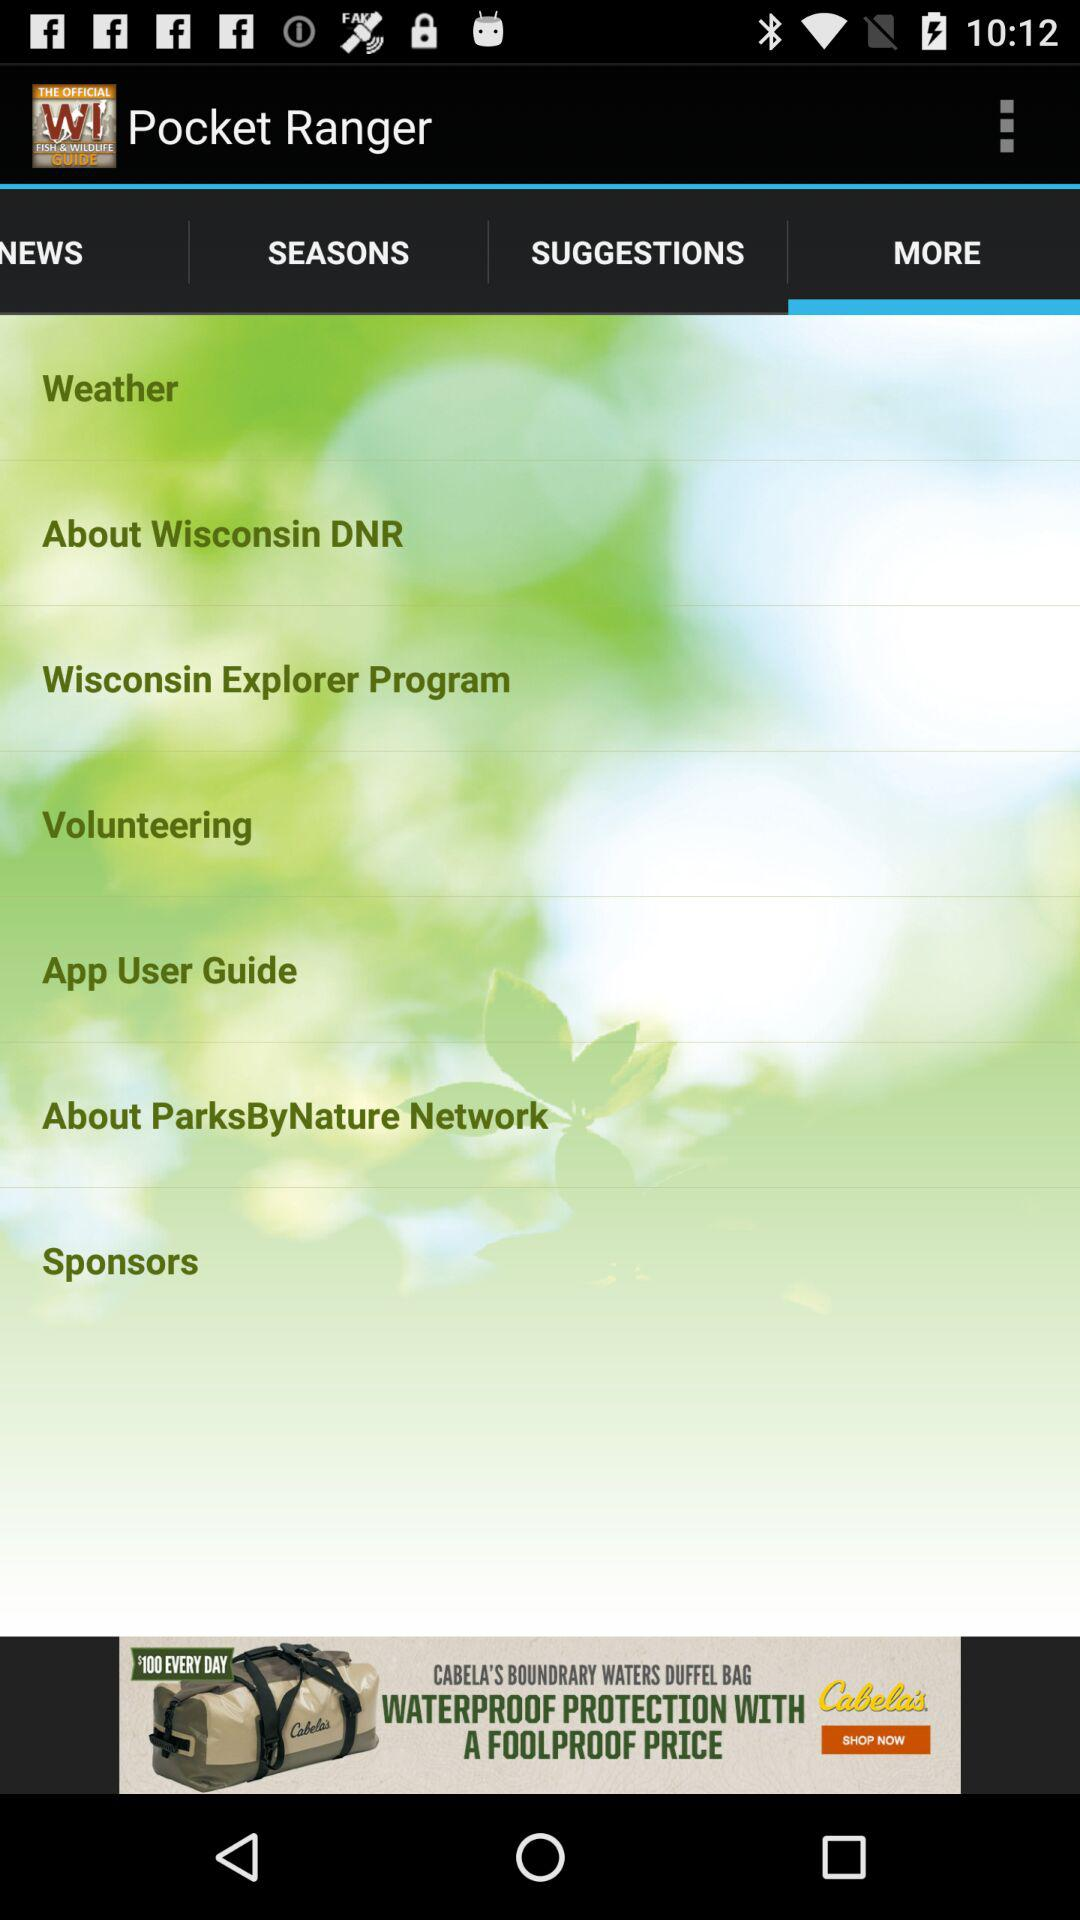Which tab is selected? The selected tab is "MORE". 